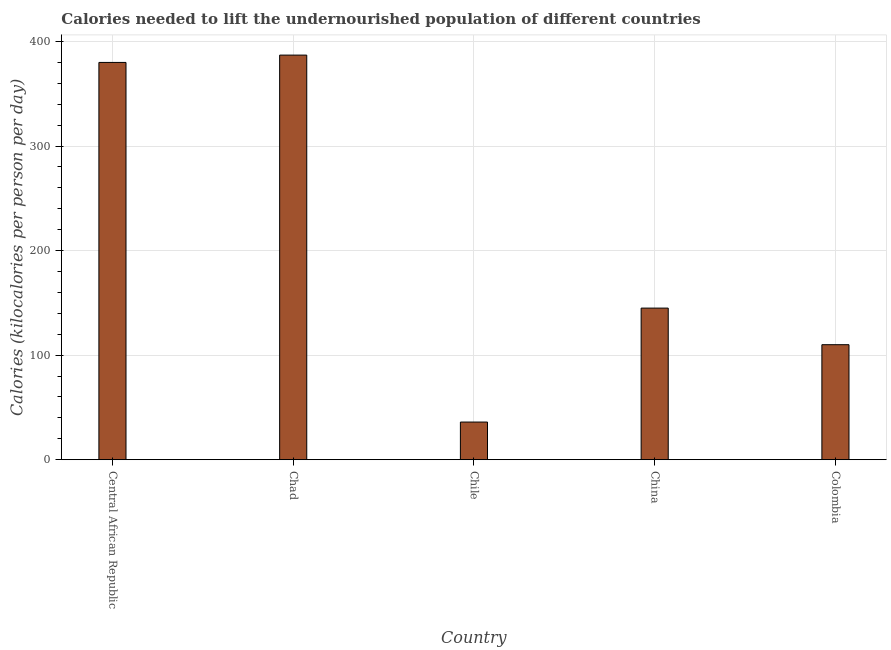What is the title of the graph?
Offer a terse response. Calories needed to lift the undernourished population of different countries. What is the label or title of the Y-axis?
Keep it short and to the point. Calories (kilocalories per person per day). What is the depth of food deficit in Central African Republic?
Provide a short and direct response. 380. Across all countries, what is the maximum depth of food deficit?
Ensure brevity in your answer.  387. In which country was the depth of food deficit maximum?
Make the answer very short. Chad. What is the sum of the depth of food deficit?
Give a very brief answer. 1058. What is the difference between the depth of food deficit in Central African Republic and China?
Provide a succinct answer. 235. What is the average depth of food deficit per country?
Provide a short and direct response. 211.6. What is the median depth of food deficit?
Ensure brevity in your answer.  145. In how many countries, is the depth of food deficit greater than 320 kilocalories?
Keep it short and to the point. 2. What is the ratio of the depth of food deficit in Central African Republic to that in Chile?
Provide a succinct answer. 10.56. Is the depth of food deficit in Chile less than that in China?
Keep it short and to the point. Yes. Is the difference between the depth of food deficit in Central African Republic and Chile greater than the difference between any two countries?
Keep it short and to the point. No. Is the sum of the depth of food deficit in Chile and Colombia greater than the maximum depth of food deficit across all countries?
Offer a very short reply. No. What is the difference between the highest and the lowest depth of food deficit?
Provide a short and direct response. 351. How many bars are there?
Provide a short and direct response. 5. How many countries are there in the graph?
Make the answer very short. 5. What is the difference between two consecutive major ticks on the Y-axis?
Give a very brief answer. 100. Are the values on the major ticks of Y-axis written in scientific E-notation?
Your answer should be compact. No. What is the Calories (kilocalories per person per day) of Central African Republic?
Give a very brief answer. 380. What is the Calories (kilocalories per person per day) of Chad?
Ensure brevity in your answer.  387. What is the Calories (kilocalories per person per day) of China?
Give a very brief answer. 145. What is the Calories (kilocalories per person per day) of Colombia?
Provide a short and direct response. 110. What is the difference between the Calories (kilocalories per person per day) in Central African Republic and Chile?
Your answer should be compact. 344. What is the difference between the Calories (kilocalories per person per day) in Central African Republic and China?
Provide a succinct answer. 235. What is the difference between the Calories (kilocalories per person per day) in Central African Republic and Colombia?
Your answer should be very brief. 270. What is the difference between the Calories (kilocalories per person per day) in Chad and Chile?
Provide a short and direct response. 351. What is the difference between the Calories (kilocalories per person per day) in Chad and China?
Your answer should be compact. 242. What is the difference between the Calories (kilocalories per person per day) in Chad and Colombia?
Your answer should be compact. 277. What is the difference between the Calories (kilocalories per person per day) in Chile and China?
Provide a short and direct response. -109. What is the difference between the Calories (kilocalories per person per day) in Chile and Colombia?
Your answer should be very brief. -74. What is the ratio of the Calories (kilocalories per person per day) in Central African Republic to that in Chad?
Make the answer very short. 0.98. What is the ratio of the Calories (kilocalories per person per day) in Central African Republic to that in Chile?
Make the answer very short. 10.56. What is the ratio of the Calories (kilocalories per person per day) in Central African Republic to that in China?
Ensure brevity in your answer.  2.62. What is the ratio of the Calories (kilocalories per person per day) in Central African Republic to that in Colombia?
Make the answer very short. 3.46. What is the ratio of the Calories (kilocalories per person per day) in Chad to that in Chile?
Keep it short and to the point. 10.75. What is the ratio of the Calories (kilocalories per person per day) in Chad to that in China?
Make the answer very short. 2.67. What is the ratio of the Calories (kilocalories per person per day) in Chad to that in Colombia?
Your answer should be very brief. 3.52. What is the ratio of the Calories (kilocalories per person per day) in Chile to that in China?
Make the answer very short. 0.25. What is the ratio of the Calories (kilocalories per person per day) in Chile to that in Colombia?
Your response must be concise. 0.33. What is the ratio of the Calories (kilocalories per person per day) in China to that in Colombia?
Ensure brevity in your answer.  1.32. 